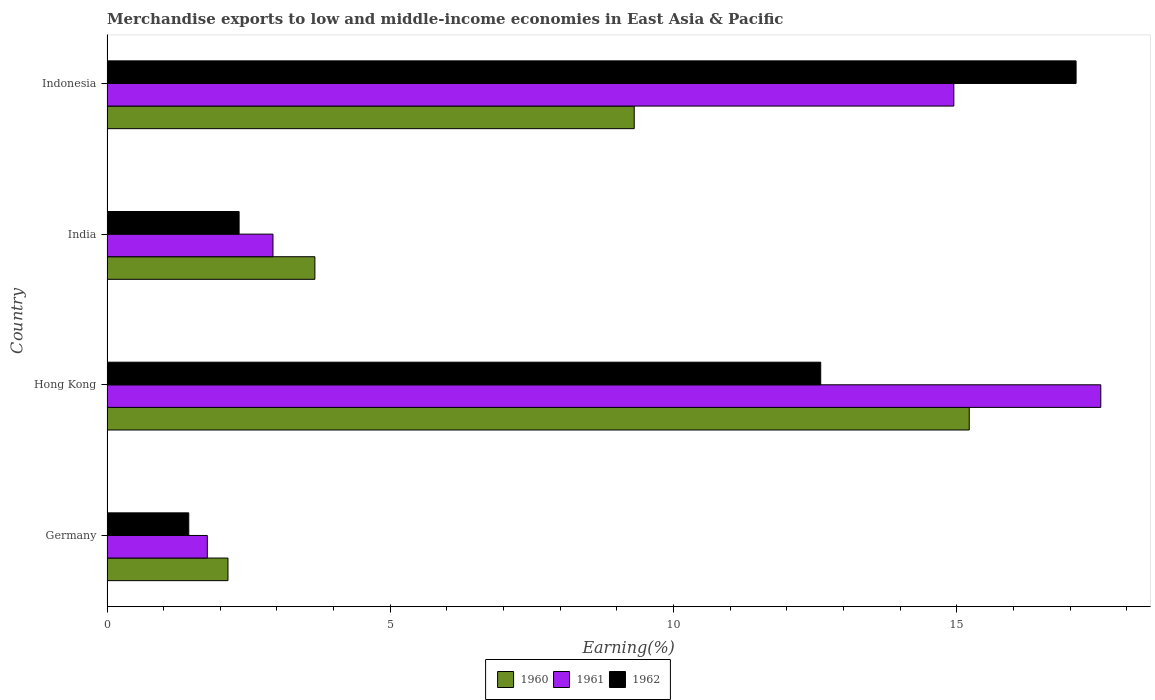How many groups of bars are there?
Ensure brevity in your answer.  4. Are the number of bars per tick equal to the number of legend labels?
Provide a short and direct response. Yes. How many bars are there on the 3rd tick from the top?
Make the answer very short. 3. How many bars are there on the 3rd tick from the bottom?
Give a very brief answer. 3. What is the label of the 2nd group of bars from the top?
Provide a succinct answer. India. In how many cases, is the number of bars for a given country not equal to the number of legend labels?
Offer a very short reply. 0. What is the percentage of amount earned from merchandise exports in 1962 in Indonesia?
Your response must be concise. 17.11. Across all countries, what is the maximum percentage of amount earned from merchandise exports in 1962?
Your response must be concise. 17.11. Across all countries, what is the minimum percentage of amount earned from merchandise exports in 1960?
Offer a terse response. 2.14. In which country was the percentage of amount earned from merchandise exports in 1961 maximum?
Your response must be concise. Hong Kong. In which country was the percentage of amount earned from merchandise exports in 1961 minimum?
Ensure brevity in your answer.  Germany. What is the total percentage of amount earned from merchandise exports in 1960 in the graph?
Provide a succinct answer. 30.33. What is the difference between the percentage of amount earned from merchandise exports in 1962 in Hong Kong and that in Indonesia?
Keep it short and to the point. -4.51. What is the difference between the percentage of amount earned from merchandise exports in 1961 in Germany and the percentage of amount earned from merchandise exports in 1960 in Indonesia?
Your answer should be compact. -7.54. What is the average percentage of amount earned from merchandise exports in 1961 per country?
Offer a terse response. 9.3. What is the difference between the percentage of amount earned from merchandise exports in 1960 and percentage of amount earned from merchandise exports in 1961 in Germany?
Your response must be concise. 0.36. What is the ratio of the percentage of amount earned from merchandise exports in 1961 in Hong Kong to that in India?
Your answer should be very brief. 5.99. Is the percentage of amount earned from merchandise exports in 1962 in Germany less than that in India?
Ensure brevity in your answer.  Yes. What is the difference between the highest and the second highest percentage of amount earned from merchandise exports in 1961?
Make the answer very short. 2.59. What is the difference between the highest and the lowest percentage of amount earned from merchandise exports in 1962?
Give a very brief answer. 15.66. In how many countries, is the percentage of amount earned from merchandise exports in 1960 greater than the average percentage of amount earned from merchandise exports in 1960 taken over all countries?
Your response must be concise. 2. Is the sum of the percentage of amount earned from merchandise exports in 1961 in Hong Kong and India greater than the maximum percentage of amount earned from merchandise exports in 1960 across all countries?
Offer a very short reply. Yes. What does the 1st bar from the top in Germany represents?
Offer a terse response. 1962. What does the 1st bar from the bottom in Hong Kong represents?
Your answer should be very brief. 1960. Is it the case that in every country, the sum of the percentage of amount earned from merchandise exports in 1962 and percentage of amount earned from merchandise exports in 1961 is greater than the percentage of amount earned from merchandise exports in 1960?
Provide a short and direct response. Yes. How many bars are there?
Keep it short and to the point. 12. Are all the bars in the graph horizontal?
Provide a succinct answer. Yes. How many countries are there in the graph?
Provide a succinct answer. 4. What is the difference between two consecutive major ticks on the X-axis?
Provide a short and direct response. 5. Are the values on the major ticks of X-axis written in scientific E-notation?
Provide a short and direct response. No. Does the graph contain any zero values?
Provide a succinct answer. No. Does the graph contain grids?
Your answer should be compact. No. How are the legend labels stacked?
Keep it short and to the point. Horizontal. What is the title of the graph?
Provide a succinct answer. Merchandise exports to low and middle-income economies in East Asia & Pacific. What is the label or title of the X-axis?
Your answer should be compact. Earning(%). What is the label or title of the Y-axis?
Your answer should be very brief. Country. What is the Earning(%) in 1960 in Germany?
Offer a very short reply. 2.14. What is the Earning(%) of 1961 in Germany?
Provide a succinct answer. 1.77. What is the Earning(%) of 1962 in Germany?
Make the answer very short. 1.44. What is the Earning(%) in 1960 in Hong Kong?
Make the answer very short. 15.22. What is the Earning(%) of 1961 in Hong Kong?
Provide a short and direct response. 17.54. What is the Earning(%) in 1962 in Hong Kong?
Give a very brief answer. 12.6. What is the Earning(%) of 1960 in India?
Your response must be concise. 3.67. What is the Earning(%) in 1961 in India?
Provide a succinct answer. 2.93. What is the Earning(%) of 1962 in India?
Provide a succinct answer. 2.33. What is the Earning(%) of 1960 in Indonesia?
Offer a terse response. 9.31. What is the Earning(%) in 1961 in Indonesia?
Offer a terse response. 14.95. What is the Earning(%) of 1962 in Indonesia?
Your answer should be very brief. 17.11. Across all countries, what is the maximum Earning(%) in 1960?
Make the answer very short. 15.22. Across all countries, what is the maximum Earning(%) of 1961?
Your response must be concise. 17.54. Across all countries, what is the maximum Earning(%) in 1962?
Provide a short and direct response. 17.11. Across all countries, what is the minimum Earning(%) in 1960?
Offer a very short reply. 2.14. Across all countries, what is the minimum Earning(%) in 1961?
Offer a terse response. 1.77. Across all countries, what is the minimum Earning(%) in 1962?
Give a very brief answer. 1.44. What is the total Earning(%) in 1960 in the graph?
Ensure brevity in your answer.  30.33. What is the total Earning(%) in 1961 in the graph?
Your response must be concise. 37.19. What is the total Earning(%) of 1962 in the graph?
Ensure brevity in your answer.  33.48. What is the difference between the Earning(%) in 1960 in Germany and that in Hong Kong?
Provide a short and direct response. -13.08. What is the difference between the Earning(%) in 1961 in Germany and that in Hong Kong?
Your answer should be compact. -15.77. What is the difference between the Earning(%) in 1962 in Germany and that in Hong Kong?
Make the answer very short. -11.16. What is the difference between the Earning(%) of 1960 in Germany and that in India?
Offer a terse response. -1.53. What is the difference between the Earning(%) of 1961 in Germany and that in India?
Provide a short and direct response. -1.16. What is the difference between the Earning(%) in 1962 in Germany and that in India?
Your answer should be compact. -0.89. What is the difference between the Earning(%) of 1960 in Germany and that in Indonesia?
Your response must be concise. -7.17. What is the difference between the Earning(%) in 1961 in Germany and that in Indonesia?
Ensure brevity in your answer.  -13.18. What is the difference between the Earning(%) in 1962 in Germany and that in Indonesia?
Make the answer very short. -15.66. What is the difference between the Earning(%) of 1960 in Hong Kong and that in India?
Your answer should be compact. 11.55. What is the difference between the Earning(%) in 1961 in Hong Kong and that in India?
Make the answer very short. 14.61. What is the difference between the Earning(%) of 1962 in Hong Kong and that in India?
Your answer should be very brief. 10.27. What is the difference between the Earning(%) in 1960 in Hong Kong and that in Indonesia?
Your answer should be very brief. 5.91. What is the difference between the Earning(%) in 1961 in Hong Kong and that in Indonesia?
Keep it short and to the point. 2.59. What is the difference between the Earning(%) in 1962 in Hong Kong and that in Indonesia?
Offer a very short reply. -4.51. What is the difference between the Earning(%) in 1960 in India and that in Indonesia?
Offer a very short reply. -5.64. What is the difference between the Earning(%) in 1961 in India and that in Indonesia?
Give a very brief answer. -12.02. What is the difference between the Earning(%) of 1962 in India and that in Indonesia?
Provide a short and direct response. -14.77. What is the difference between the Earning(%) of 1960 in Germany and the Earning(%) of 1961 in Hong Kong?
Keep it short and to the point. -15.41. What is the difference between the Earning(%) in 1960 in Germany and the Earning(%) in 1962 in Hong Kong?
Provide a succinct answer. -10.46. What is the difference between the Earning(%) in 1961 in Germany and the Earning(%) in 1962 in Hong Kong?
Keep it short and to the point. -10.83. What is the difference between the Earning(%) in 1960 in Germany and the Earning(%) in 1961 in India?
Keep it short and to the point. -0.79. What is the difference between the Earning(%) in 1960 in Germany and the Earning(%) in 1962 in India?
Keep it short and to the point. -0.2. What is the difference between the Earning(%) in 1961 in Germany and the Earning(%) in 1962 in India?
Offer a very short reply. -0.56. What is the difference between the Earning(%) in 1960 in Germany and the Earning(%) in 1961 in Indonesia?
Your response must be concise. -12.81. What is the difference between the Earning(%) of 1960 in Germany and the Earning(%) of 1962 in Indonesia?
Provide a succinct answer. -14.97. What is the difference between the Earning(%) in 1961 in Germany and the Earning(%) in 1962 in Indonesia?
Offer a very short reply. -15.34. What is the difference between the Earning(%) of 1960 in Hong Kong and the Earning(%) of 1961 in India?
Provide a succinct answer. 12.29. What is the difference between the Earning(%) of 1960 in Hong Kong and the Earning(%) of 1962 in India?
Your answer should be compact. 12.89. What is the difference between the Earning(%) of 1961 in Hong Kong and the Earning(%) of 1962 in India?
Keep it short and to the point. 15.21. What is the difference between the Earning(%) in 1960 in Hong Kong and the Earning(%) in 1961 in Indonesia?
Your answer should be compact. 0.27. What is the difference between the Earning(%) of 1960 in Hong Kong and the Earning(%) of 1962 in Indonesia?
Your answer should be very brief. -1.89. What is the difference between the Earning(%) in 1961 in Hong Kong and the Earning(%) in 1962 in Indonesia?
Offer a very short reply. 0.44. What is the difference between the Earning(%) of 1960 in India and the Earning(%) of 1961 in Indonesia?
Your response must be concise. -11.28. What is the difference between the Earning(%) of 1960 in India and the Earning(%) of 1962 in Indonesia?
Make the answer very short. -13.44. What is the difference between the Earning(%) of 1961 in India and the Earning(%) of 1962 in Indonesia?
Your response must be concise. -14.18. What is the average Earning(%) in 1960 per country?
Your answer should be compact. 7.58. What is the average Earning(%) of 1961 per country?
Your response must be concise. 9.3. What is the average Earning(%) of 1962 per country?
Ensure brevity in your answer.  8.37. What is the difference between the Earning(%) of 1960 and Earning(%) of 1961 in Germany?
Provide a short and direct response. 0.36. What is the difference between the Earning(%) of 1960 and Earning(%) of 1962 in Germany?
Your response must be concise. 0.69. What is the difference between the Earning(%) in 1961 and Earning(%) in 1962 in Germany?
Your answer should be very brief. 0.33. What is the difference between the Earning(%) of 1960 and Earning(%) of 1961 in Hong Kong?
Give a very brief answer. -2.32. What is the difference between the Earning(%) in 1960 and Earning(%) in 1962 in Hong Kong?
Your answer should be compact. 2.62. What is the difference between the Earning(%) of 1961 and Earning(%) of 1962 in Hong Kong?
Your response must be concise. 4.94. What is the difference between the Earning(%) in 1960 and Earning(%) in 1961 in India?
Offer a terse response. 0.74. What is the difference between the Earning(%) of 1960 and Earning(%) of 1962 in India?
Provide a succinct answer. 1.34. What is the difference between the Earning(%) of 1961 and Earning(%) of 1962 in India?
Your answer should be compact. 0.6. What is the difference between the Earning(%) in 1960 and Earning(%) in 1961 in Indonesia?
Your answer should be very brief. -5.64. What is the difference between the Earning(%) in 1960 and Earning(%) in 1962 in Indonesia?
Provide a succinct answer. -7.8. What is the difference between the Earning(%) in 1961 and Earning(%) in 1962 in Indonesia?
Your answer should be very brief. -2.16. What is the ratio of the Earning(%) in 1960 in Germany to that in Hong Kong?
Keep it short and to the point. 0.14. What is the ratio of the Earning(%) in 1961 in Germany to that in Hong Kong?
Your answer should be very brief. 0.1. What is the ratio of the Earning(%) in 1962 in Germany to that in Hong Kong?
Make the answer very short. 0.11. What is the ratio of the Earning(%) of 1960 in Germany to that in India?
Provide a succinct answer. 0.58. What is the ratio of the Earning(%) in 1961 in Germany to that in India?
Keep it short and to the point. 0.6. What is the ratio of the Earning(%) in 1962 in Germany to that in India?
Provide a short and direct response. 0.62. What is the ratio of the Earning(%) of 1960 in Germany to that in Indonesia?
Offer a very short reply. 0.23. What is the ratio of the Earning(%) of 1961 in Germany to that in Indonesia?
Keep it short and to the point. 0.12. What is the ratio of the Earning(%) in 1962 in Germany to that in Indonesia?
Keep it short and to the point. 0.08. What is the ratio of the Earning(%) of 1960 in Hong Kong to that in India?
Your response must be concise. 4.15. What is the ratio of the Earning(%) of 1961 in Hong Kong to that in India?
Ensure brevity in your answer.  5.99. What is the ratio of the Earning(%) in 1962 in Hong Kong to that in India?
Your answer should be very brief. 5.4. What is the ratio of the Earning(%) of 1960 in Hong Kong to that in Indonesia?
Your answer should be compact. 1.64. What is the ratio of the Earning(%) of 1961 in Hong Kong to that in Indonesia?
Offer a very short reply. 1.17. What is the ratio of the Earning(%) of 1962 in Hong Kong to that in Indonesia?
Your answer should be compact. 0.74. What is the ratio of the Earning(%) of 1960 in India to that in Indonesia?
Provide a succinct answer. 0.39. What is the ratio of the Earning(%) of 1961 in India to that in Indonesia?
Make the answer very short. 0.2. What is the ratio of the Earning(%) in 1962 in India to that in Indonesia?
Make the answer very short. 0.14. What is the difference between the highest and the second highest Earning(%) in 1960?
Provide a short and direct response. 5.91. What is the difference between the highest and the second highest Earning(%) in 1961?
Offer a very short reply. 2.59. What is the difference between the highest and the second highest Earning(%) in 1962?
Provide a short and direct response. 4.51. What is the difference between the highest and the lowest Earning(%) of 1960?
Keep it short and to the point. 13.08. What is the difference between the highest and the lowest Earning(%) in 1961?
Provide a succinct answer. 15.77. What is the difference between the highest and the lowest Earning(%) in 1962?
Provide a short and direct response. 15.66. 